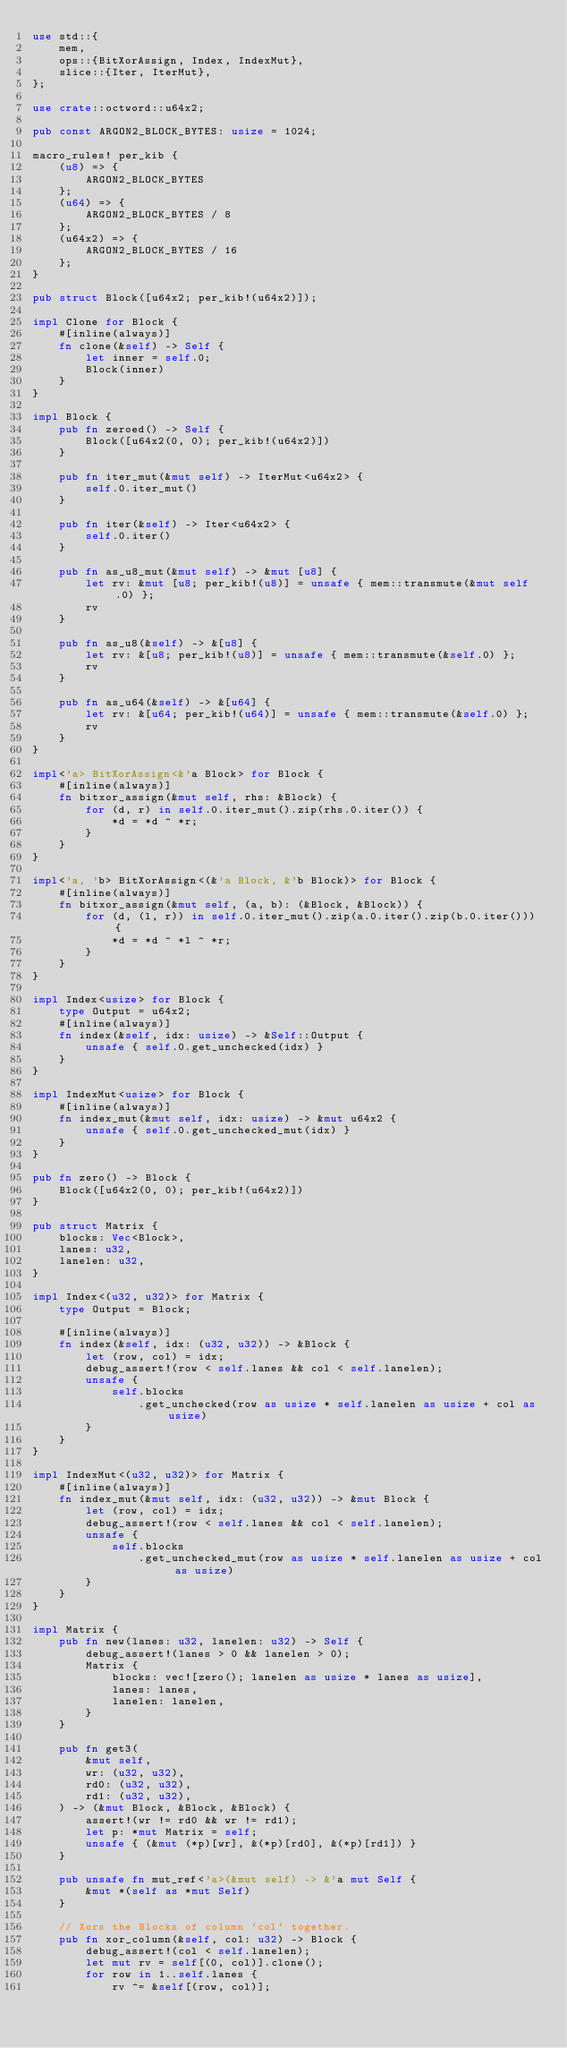<code> <loc_0><loc_0><loc_500><loc_500><_Rust_>use std::{
    mem,
    ops::{BitXorAssign, Index, IndexMut},
    slice::{Iter, IterMut},
};

use crate::octword::u64x2;

pub const ARGON2_BLOCK_BYTES: usize = 1024;

macro_rules! per_kib {
    (u8) => {
        ARGON2_BLOCK_BYTES
    };
    (u64) => {
        ARGON2_BLOCK_BYTES / 8
    };
    (u64x2) => {
        ARGON2_BLOCK_BYTES / 16
    };
}

pub struct Block([u64x2; per_kib!(u64x2)]);

impl Clone for Block {
    #[inline(always)]
    fn clone(&self) -> Self {
        let inner = self.0;
        Block(inner)
    }
}

impl Block {
    pub fn zeroed() -> Self {
        Block([u64x2(0, 0); per_kib!(u64x2)])
    }

    pub fn iter_mut(&mut self) -> IterMut<u64x2> {
        self.0.iter_mut()
    }

    pub fn iter(&self) -> Iter<u64x2> {
        self.0.iter()
    }

    pub fn as_u8_mut(&mut self) -> &mut [u8] {
        let rv: &mut [u8; per_kib!(u8)] = unsafe { mem::transmute(&mut self.0) };
        rv
    }

    pub fn as_u8(&self) -> &[u8] {
        let rv: &[u8; per_kib!(u8)] = unsafe { mem::transmute(&self.0) };
        rv
    }

    pub fn as_u64(&self) -> &[u64] {
        let rv: &[u64; per_kib!(u64)] = unsafe { mem::transmute(&self.0) };
        rv
    }
}

impl<'a> BitXorAssign<&'a Block> for Block {
    #[inline(always)]
    fn bitxor_assign(&mut self, rhs: &Block) {
        for (d, r) in self.0.iter_mut().zip(rhs.0.iter()) {
            *d = *d ^ *r;
        }
    }
}

impl<'a, 'b> BitXorAssign<(&'a Block, &'b Block)> for Block {
    #[inline(always)]
    fn bitxor_assign(&mut self, (a, b): (&Block, &Block)) {
        for (d, (l, r)) in self.0.iter_mut().zip(a.0.iter().zip(b.0.iter())) {
            *d = *d ^ *l ^ *r;
        }
    }
}

impl Index<usize> for Block {
    type Output = u64x2;
    #[inline(always)]
    fn index(&self, idx: usize) -> &Self::Output {
        unsafe { self.0.get_unchecked(idx) }
    }
}

impl IndexMut<usize> for Block {
    #[inline(always)]
    fn index_mut(&mut self, idx: usize) -> &mut u64x2 {
        unsafe { self.0.get_unchecked_mut(idx) }
    }
}

pub fn zero() -> Block {
    Block([u64x2(0, 0); per_kib!(u64x2)])
}

pub struct Matrix {
    blocks: Vec<Block>,
    lanes: u32,
    lanelen: u32,
}

impl Index<(u32, u32)> for Matrix {
    type Output = Block;

    #[inline(always)]
    fn index(&self, idx: (u32, u32)) -> &Block {
        let (row, col) = idx;
        debug_assert!(row < self.lanes && col < self.lanelen);
        unsafe {
            self.blocks
                .get_unchecked(row as usize * self.lanelen as usize + col as usize)
        }
    }
}

impl IndexMut<(u32, u32)> for Matrix {
    #[inline(always)]
    fn index_mut(&mut self, idx: (u32, u32)) -> &mut Block {
        let (row, col) = idx;
        debug_assert!(row < self.lanes && col < self.lanelen);
        unsafe {
            self.blocks
                .get_unchecked_mut(row as usize * self.lanelen as usize + col as usize)
        }
    }
}

impl Matrix {
    pub fn new(lanes: u32, lanelen: u32) -> Self {
        debug_assert!(lanes > 0 && lanelen > 0);
        Matrix {
            blocks: vec![zero(); lanelen as usize * lanes as usize],
            lanes: lanes,
            lanelen: lanelen,
        }
    }

    pub fn get3(
        &mut self,
        wr: (u32, u32),
        rd0: (u32, u32),
        rd1: (u32, u32),
    ) -> (&mut Block, &Block, &Block) {
        assert!(wr != rd0 && wr != rd1);
        let p: *mut Matrix = self;
        unsafe { (&mut (*p)[wr], &(*p)[rd0], &(*p)[rd1]) }
    }

    pub unsafe fn mut_ref<'a>(&mut self) -> &'a mut Self {
        &mut *(self as *mut Self)
    }

    // Xors the Blocks of column `col` together.
    pub fn xor_column(&self, col: u32) -> Block {
        debug_assert!(col < self.lanelen);
        let mut rv = self[(0, col)].clone();
        for row in 1..self.lanes {
            rv ^= &self[(row, col)];</code> 